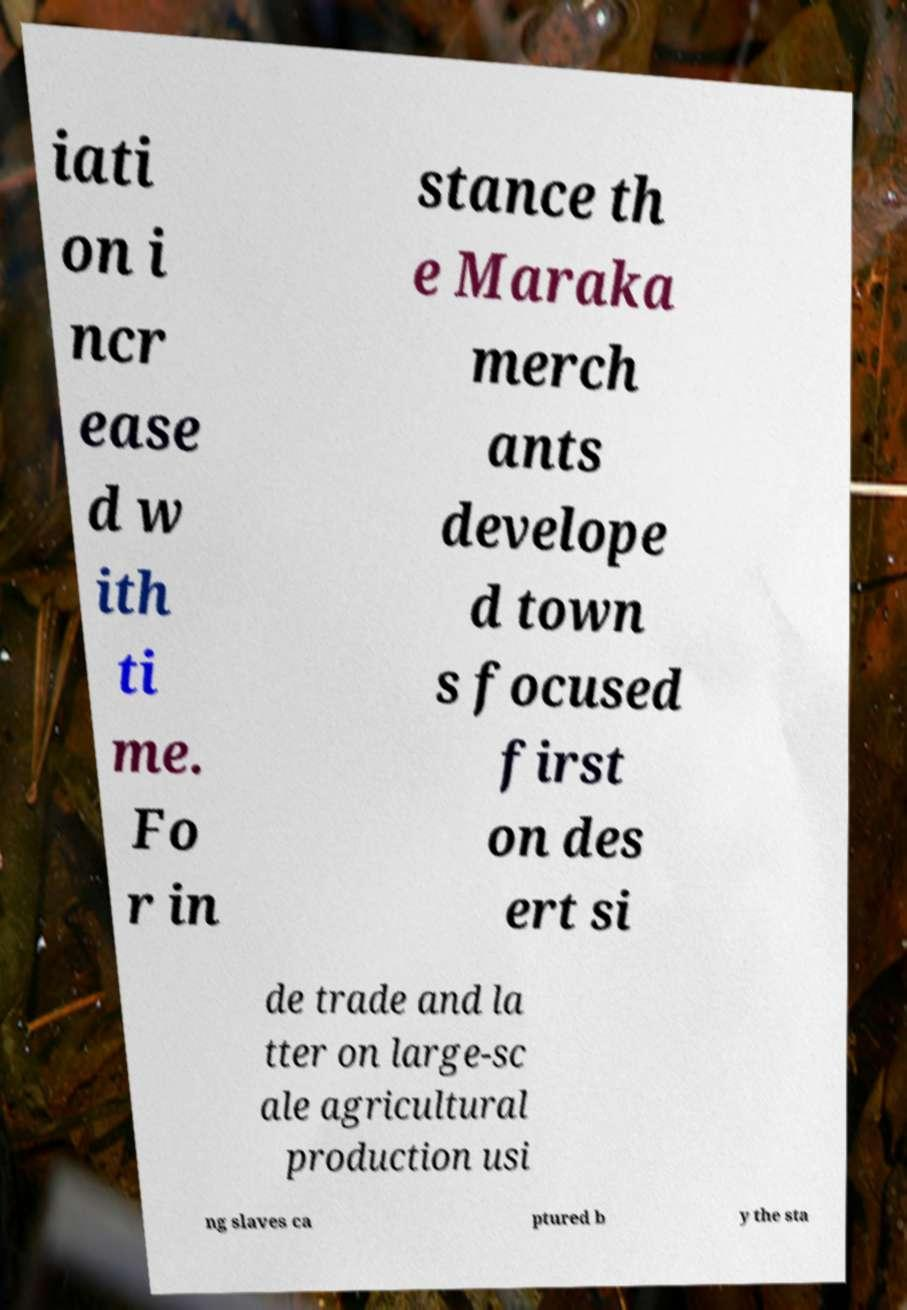There's text embedded in this image that I need extracted. Can you transcribe it verbatim? iati on i ncr ease d w ith ti me. Fo r in stance th e Maraka merch ants develope d town s focused first on des ert si de trade and la tter on large-sc ale agricultural production usi ng slaves ca ptured b y the sta 